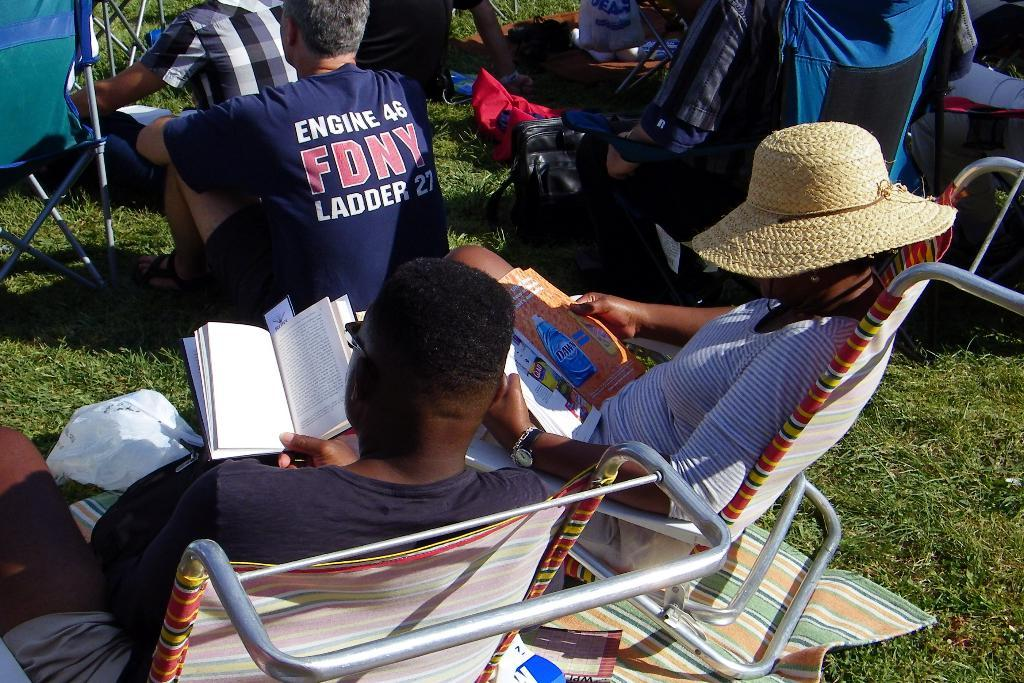Where was the image taken? The image is taken outdoors. Can you describe the people in the image? There is a group of people in the image. What are two of the people doing in the image? Two persons are sitting on chairs and reading a book. What type of cellar can be seen in the background of the image? There is no cellar present in the image; it is taken outdoors. Is there a volcano visible in the image? No, there is no volcano visible in the image. 